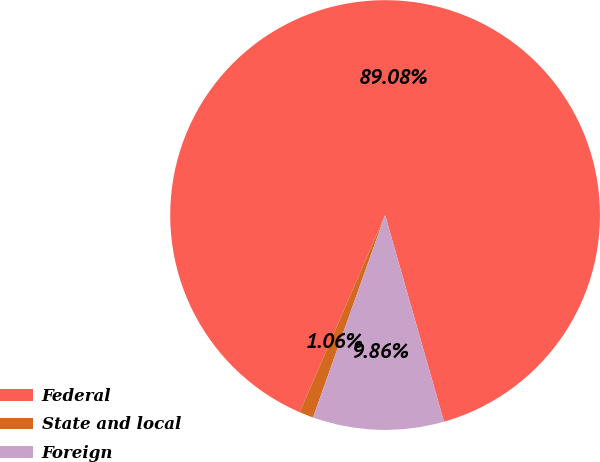Convert chart. <chart><loc_0><loc_0><loc_500><loc_500><pie_chart><fcel>Federal<fcel>State and local<fcel>Foreign<nl><fcel>89.07%<fcel>1.06%<fcel>9.86%<nl></chart> 